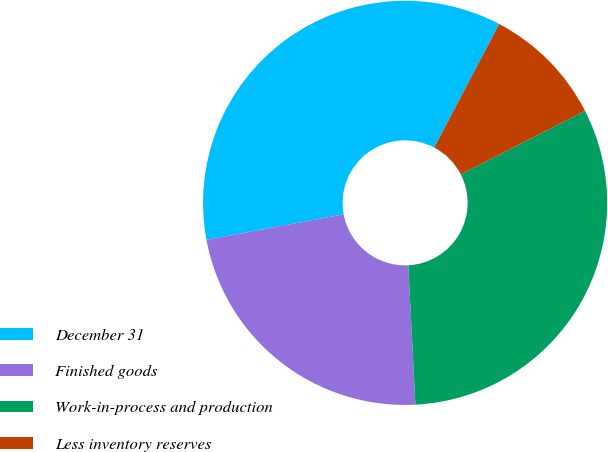Convert chart to OTSL. <chart><loc_0><loc_0><loc_500><loc_500><pie_chart><fcel>December 31<fcel>Finished goods<fcel>Work-in-process and production<fcel>Less inventory reserves<nl><fcel>35.64%<fcel>22.88%<fcel>31.72%<fcel>9.76%<nl></chart> 